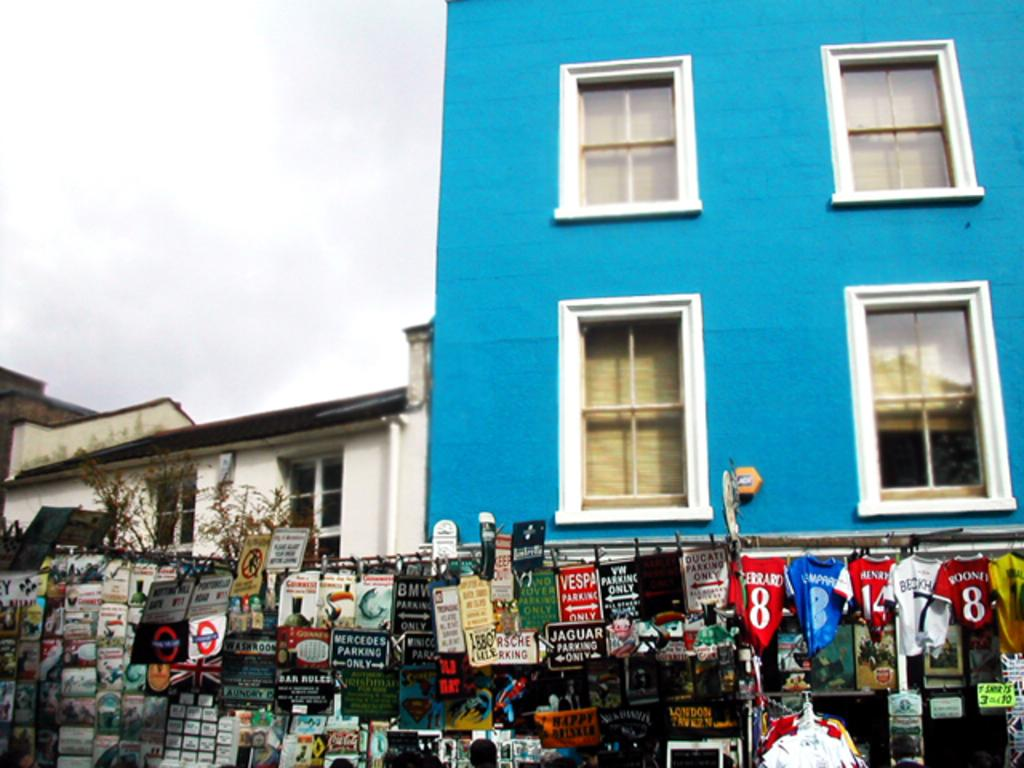What type of objects can be seen on the walls in the image? There are posters in the image. What other objects are present in the image? There are boards in the image. What type of natural elements can be seen in the image? There are trees in the image. What can be seen in the background of the image? There are buildings, windows, and the sky visible in the background of the image. What team is responsible for the history of the wrist in the image? There is no reference to a team or wrist in the image, so this question cannot be answered. 